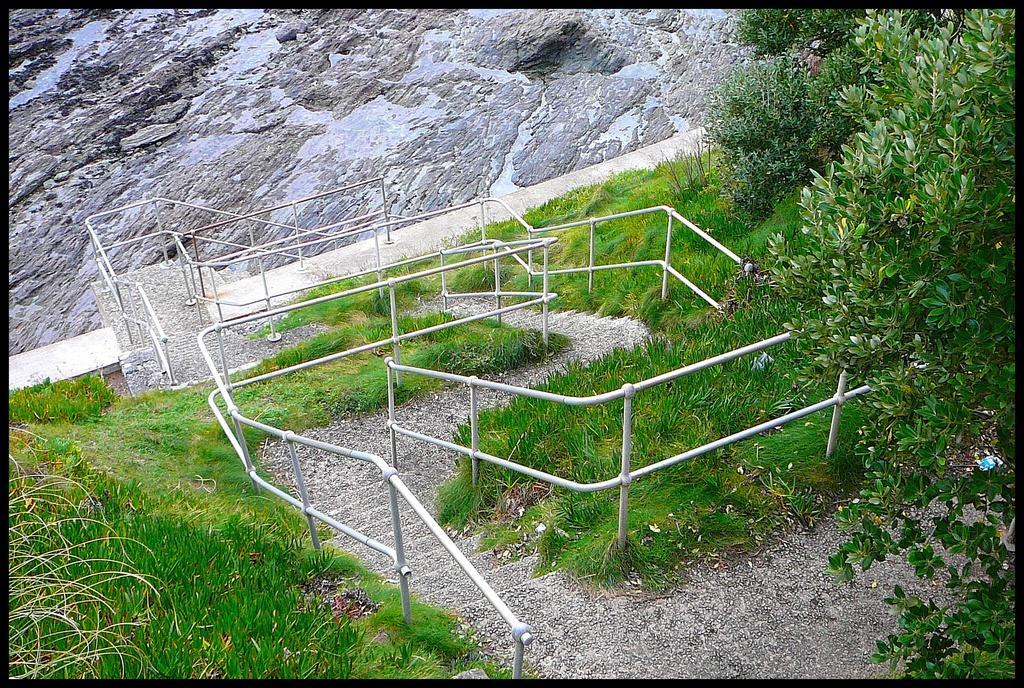Could you give a brief overview of what you see in this image? In the image there are steps and around the steps there is a lot of grass and on the right side there are trees, behind the steps there is a rock surface. 